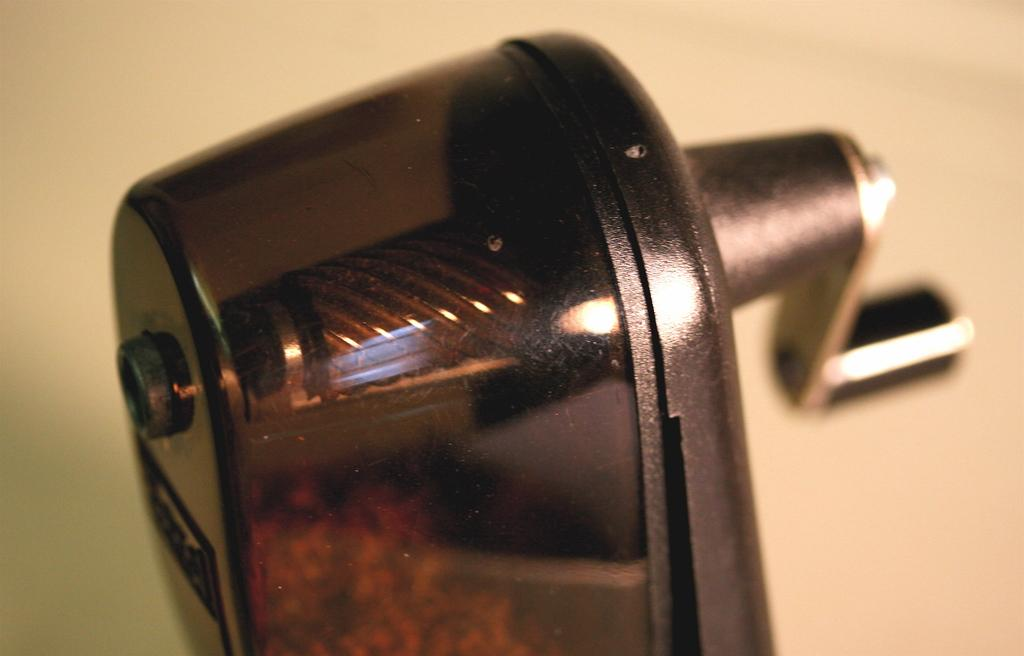What is the main object in the center of the image? There is a grater in the center of the image. What is the color of the grater? The grater is black in color. What can be seen in the background of the image? There is a wall in the background of the image. How many dinosaurs are visible behind the grater in the image? There are no dinosaurs present in the image; it only features a grater and a wall in the background. What type of bone can be seen on the grater in the image? There is no bone present on the grater in the image; it is a grater without any food items on it. 